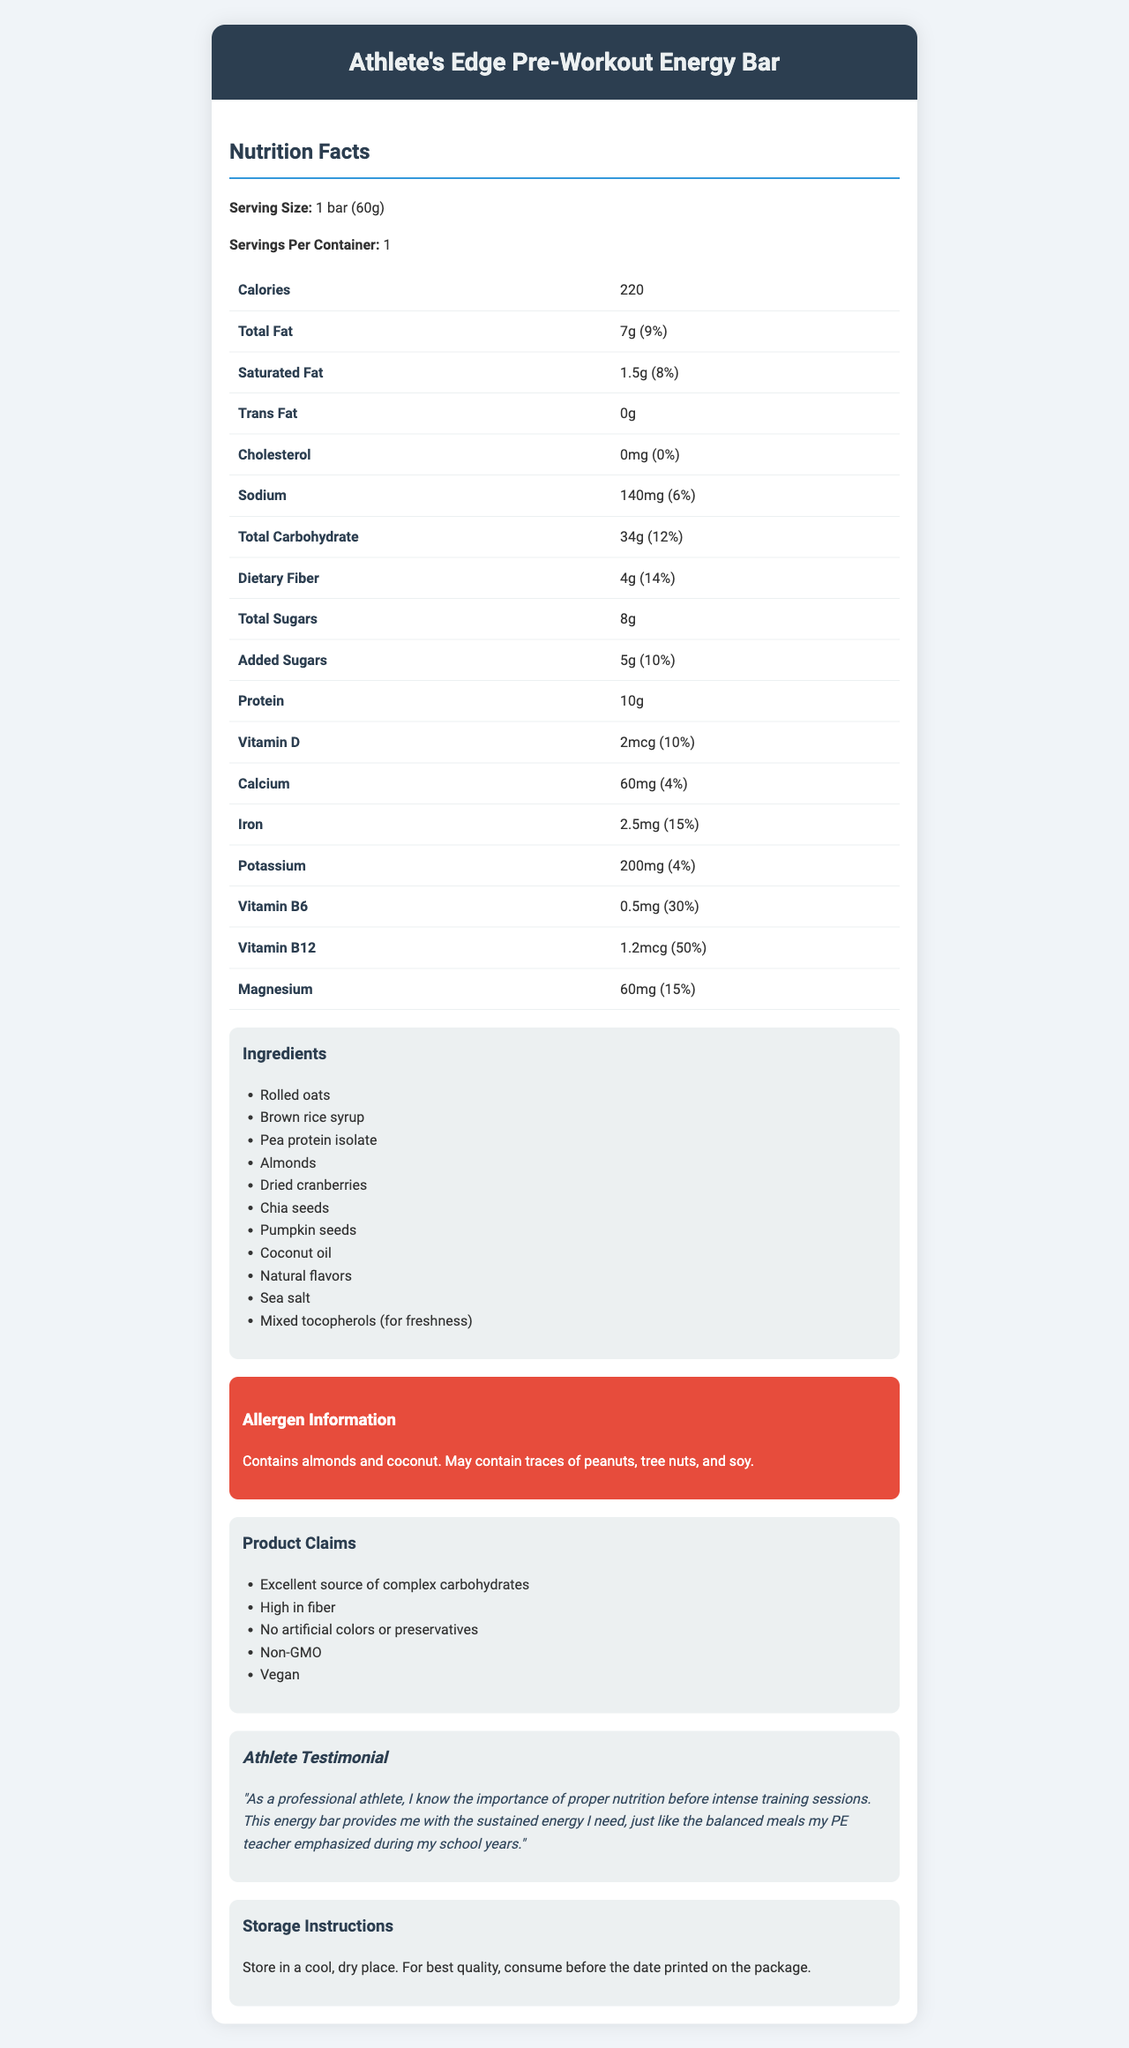what is the serving size of the energy bar? The serving size is explicitly mentioned as "1 bar (60g)" in the document.
Answer: 1 bar (60g) how many calories are there per serving? The number of calories per serving is listed as 220.
Answer: 220 what is the amount of protein in the energy bar? The protein content in the energy bar is listed as 10g.
Answer: 10g what is the percentage of daily value for saturated fat? The daily value percentage for saturated fat is listed as 8%.
Answer: 8% how much dietary fiber is in one serving? The amount of dietary fiber per serving is listed as 4g.
Answer: 4g how many grams of total sugars does the energy bar contain? The total sugars amount listed for the energy bar is 8g.
Answer: 8g what type of fats are present in the energy bar? The document lists saturated fat and indicates that there is 0g of trans fat.
Answer: Saturated Fat and Trans Fat what are the magnesium contents in the energy bar in mg? The magnesium content in one serving of the energy bar is given as 60mg.
Answer: 60mg does the energy bar contain any allergens? The allergen information specifies that it contains almonds and coconut and may contain traces of peanuts, tree nuts, and soy.
Answer: Yes what is the main carbohydrate source listed in the ingredients? Rolled oats are listed first in the ingredient list, implying it is a primary ingredient and source of carbohydrates.
Answer: Rolled oats which vitamin has the highest daily value percentage in the energy bar? 
A. Vitamin D 
B. Calcium 
C. Vitamin B6 
D. Vitamin B12 Vitamin B12 has the highest daily value percentage listed at 50%.
Answer: D what is the sodium content in one serving of the energy bar? 
i. 50mg 
ii. 140mg 
iii. 200mg 
iv. 300mg The sodium content per serving is listed as 140mg.
Answer: ii can the energy bar be considered vegan? The claims section specifies that the energy bar is vegan.
Answer: Yes is the energy bar free of artificial preservatives? The claims section states "No artificial colors or preservatives."
Answer: Yes does the energy bar contain any cholesterol? The document states that the cholesterol amount per serving is 0mg.
Answer: No summarize the main features of the Athlete's Edge Pre-Workout Energy Bar. This summary includes information on calories, macronutrients, vitamins, ingredients, and specific claims mentioned in the document.
Answer: The Athlete's Edge Pre-Workout Energy Bar is a vegan energy bar containing 220 calories per serving. It provides 34g of carbohydrates, 10g of protein, and essential vitamins like Vitamin B12 and B6. It includes ingredients like rolled oats and almonds, and is high in dietary fiber. It is free from artificial colors and preservatives but contains allergens like almonds and coconut. It aims to provide sustained energy for athletes. does the document provide any information on the taste of the energy bar? The document provides detailed nutritional information, but does not include any descriptions or reviews about the taste.
Answer: Not enough information 